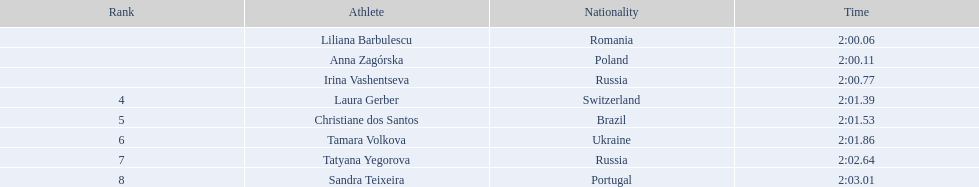What are the names of all the athletes? Liliana Barbulescu, Anna Zagórska, Irina Vashentseva, Laura Gerber, Christiane dos Santos, Tamara Volkova, Tatyana Yegorova, Sandra Teixeira. What were their respective finishing times? 2:00.06, 2:00.11, 2:00.77, 2:01.39, 2:01.53, 2:01.86, 2:02.64, 2:03.01. Which one among them crossed the finish line the earliest? Liliana Barbulescu. 